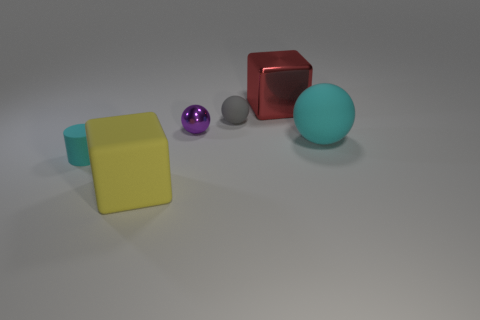Add 3 tiny yellow shiny cubes. How many objects exist? 9 Subtract all tiny balls. How many balls are left? 1 Subtract all cylinders. How many objects are left? 5 Subtract 1 spheres. How many spheres are left? 2 Add 4 large cyan balls. How many large cyan balls are left? 5 Add 2 yellow blocks. How many yellow blocks exist? 3 Subtract 0 yellow balls. How many objects are left? 6 Subtract all brown balls. Subtract all cyan cylinders. How many balls are left? 3 Subtract all large red rubber objects. Subtract all tiny spheres. How many objects are left? 4 